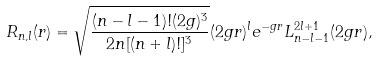<formula> <loc_0><loc_0><loc_500><loc_500>R _ { n , l } ( r ) = \sqrt { \frac { ( n - l - 1 ) ! ( 2 g ) ^ { 3 } } { 2 n [ ( n + l ) ! ] ^ { 3 } } } ( 2 g r ) ^ { l } e ^ { - g r } L _ { n - l - 1 } ^ { 2 l + 1 } ( 2 g r ) ,</formula> 